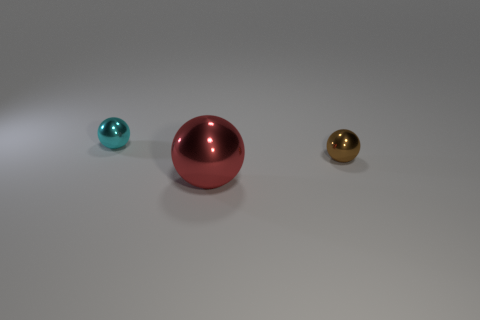Are there more objects than small blue matte blocks?
Ensure brevity in your answer.  Yes. There is another small object that is the same material as the brown object; what shape is it?
Make the answer very short. Sphere. Are there fewer green metal spheres than cyan objects?
Your answer should be compact. Yes. What is the material of the ball that is both on the left side of the brown metal ball and behind the red metallic thing?
Your response must be concise. Metal. There is a shiny sphere behind the tiny sphere to the right of the small metallic sphere left of the small brown object; what size is it?
Make the answer very short. Small. How many objects are both to the left of the big ball and to the right of the tiny cyan sphere?
Provide a succinct answer. 0. How many yellow objects are either small objects or metal spheres?
Provide a succinct answer. 0. There is a metal thing that is on the left side of the large sphere; is it the same color as the small thing that is right of the cyan object?
Offer a very short reply. No. There is a ball that is behind the tiny thing on the right side of the red metallic object on the left side of the small brown object; what is its color?
Provide a short and direct response. Cyan. There is a metal ball that is in front of the brown metallic thing; is there a thing that is left of it?
Offer a very short reply. Yes. 